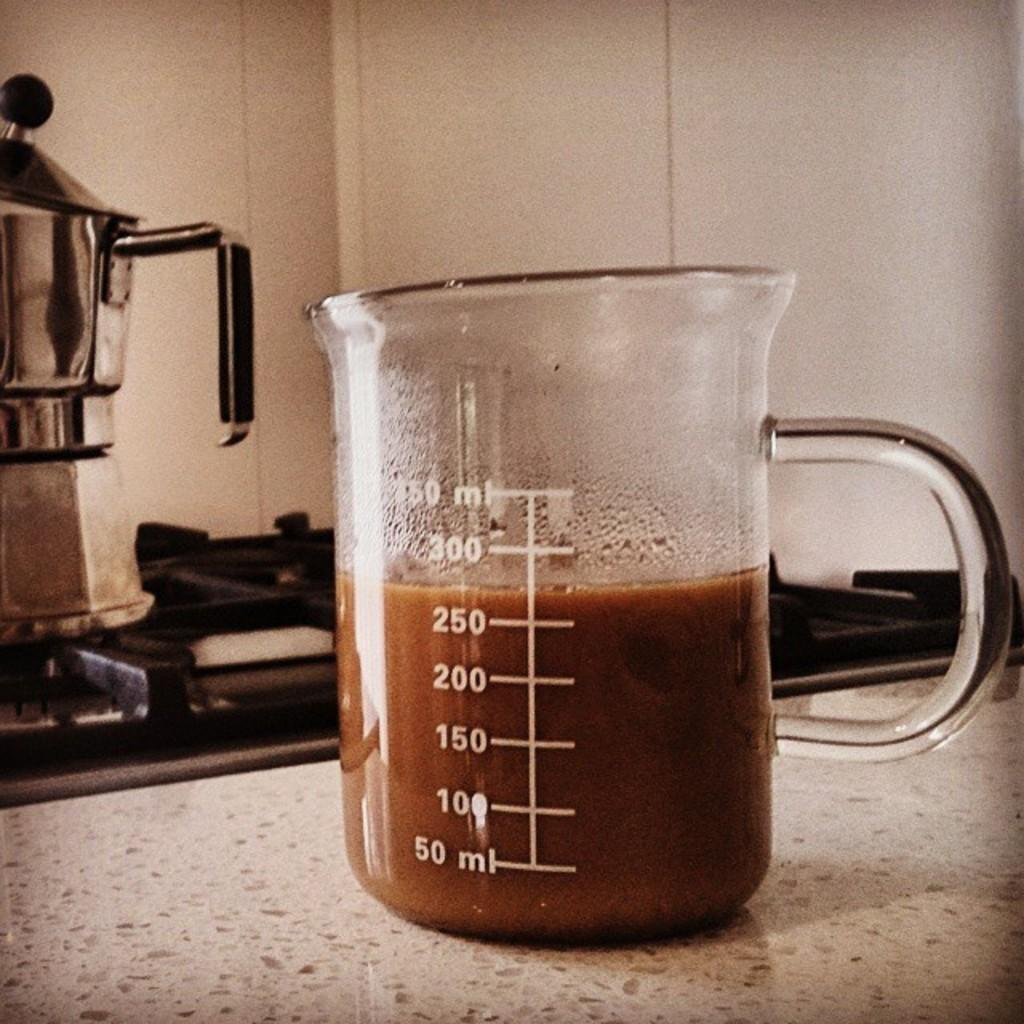<image>
Render a clear and concise summary of the photo. A glass mug filled to just over 250 ml 